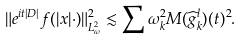Convert formula to latex. <formula><loc_0><loc_0><loc_500><loc_500>\| e ^ { i t | D | } f ( | x | \cdot ) \| _ { L ^ { 2 } _ { \omega } } ^ { 2 } \lesssim \sum \omega _ { k } ^ { 2 } M ( \widehat { g } ^ { l } _ { k } ) ( t ) ^ { 2 } .</formula> 